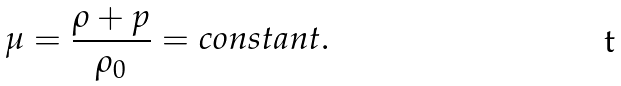Convert formula to latex. <formula><loc_0><loc_0><loc_500><loc_500>\mu = \frac { \rho + p } { \rho _ { 0 } } = c o n s t a n t .</formula> 